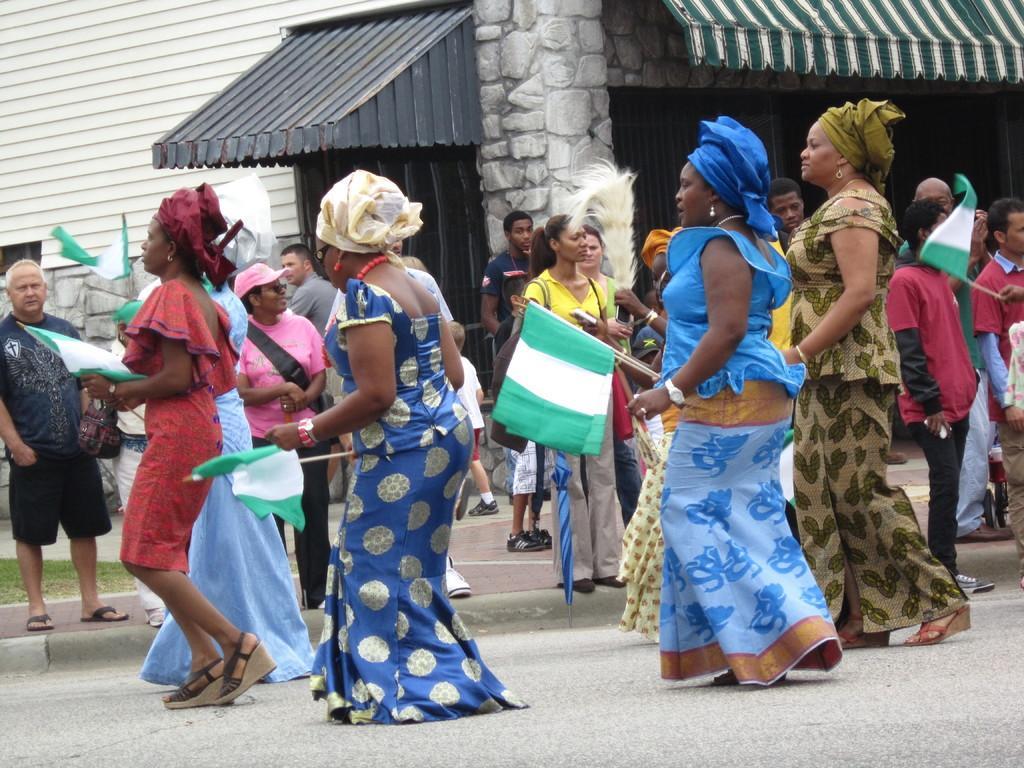Could you give a brief overview of what you see in this image? In this picture there is a group of women walking on the street, holding a green and white flags in the hand. Behind there is a house with green color canopy shed and a door. 